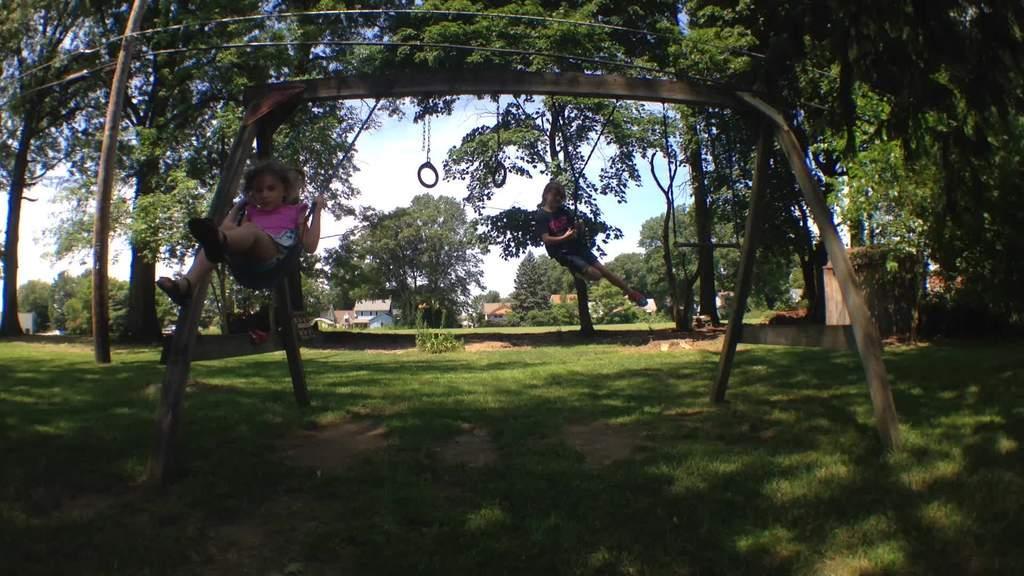How would you summarize this image in a sentence or two? In this image there are two kids who are sitting on the swing and moving up and down. At the bottom there is a ground on which there is grass. In the background there are trees. In the middle there is a house in the background. On the right side there is a wall. At the top there are rings which are hanged to the swing. There are wires at the top. 